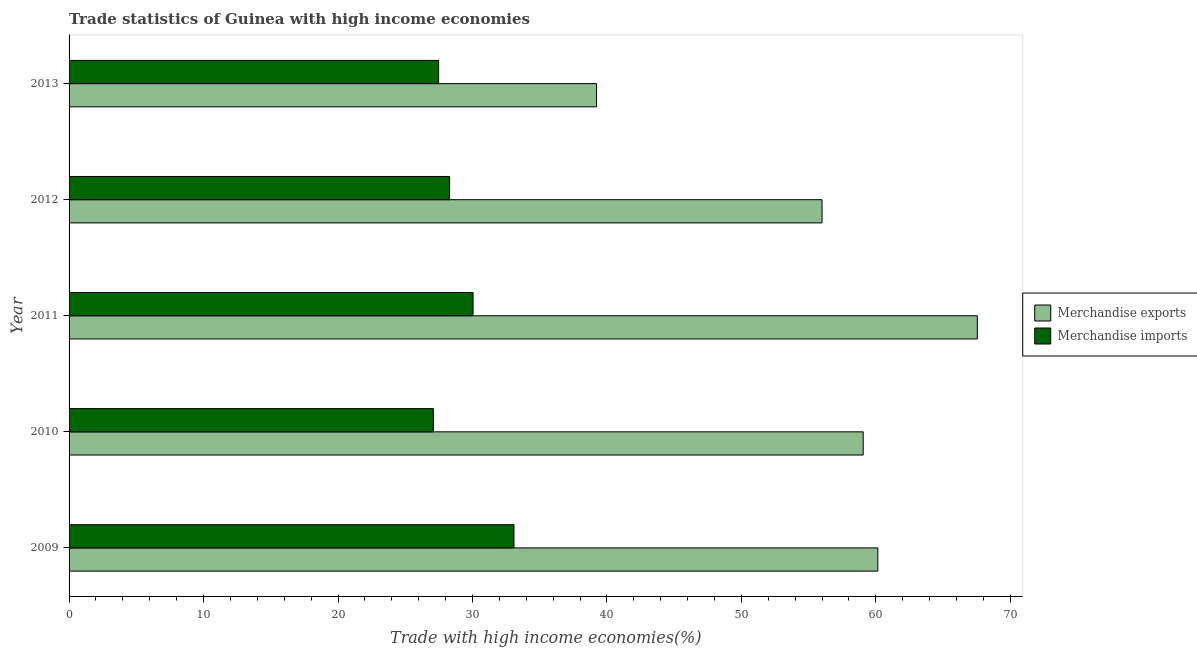Are the number of bars per tick equal to the number of legend labels?
Provide a short and direct response. Yes. Are the number of bars on each tick of the Y-axis equal?
Your response must be concise. Yes. In how many cases, is the number of bars for a given year not equal to the number of legend labels?
Offer a very short reply. 0. What is the merchandise exports in 2013?
Provide a short and direct response. 39.23. Across all years, what is the maximum merchandise imports?
Your response must be concise. 33.09. Across all years, what is the minimum merchandise imports?
Keep it short and to the point. 27.09. In which year was the merchandise exports minimum?
Your response must be concise. 2013. What is the total merchandise imports in the graph?
Make the answer very short. 146.01. What is the difference between the merchandise exports in 2009 and that in 2011?
Keep it short and to the point. -7.4. What is the difference between the merchandise imports in 2009 and the merchandise exports in 2013?
Keep it short and to the point. -6.14. What is the average merchandise imports per year?
Give a very brief answer. 29.2. In the year 2010, what is the difference between the merchandise imports and merchandise exports?
Your answer should be compact. -31.96. What is the ratio of the merchandise exports in 2009 to that in 2013?
Keep it short and to the point. 1.53. Is the merchandise exports in 2009 less than that in 2012?
Ensure brevity in your answer.  No. Is the difference between the merchandise imports in 2010 and 2011 greater than the difference between the merchandise exports in 2010 and 2011?
Ensure brevity in your answer.  Yes. What is the difference between the highest and the second highest merchandise imports?
Offer a very short reply. 3.04. What is the difference between the highest and the lowest merchandise exports?
Offer a terse response. 28.32. Is the sum of the merchandise imports in 2012 and 2013 greater than the maximum merchandise exports across all years?
Make the answer very short. No. What does the 2nd bar from the top in 2013 represents?
Make the answer very short. Merchandise exports. How many bars are there?
Provide a short and direct response. 10. What is the difference between two consecutive major ticks on the X-axis?
Provide a short and direct response. 10. Are the values on the major ticks of X-axis written in scientific E-notation?
Your answer should be compact. No. Does the graph contain any zero values?
Give a very brief answer. No. Does the graph contain grids?
Provide a short and direct response. No. What is the title of the graph?
Your answer should be compact. Trade statistics of Guinea with high income economies. Does "Register a business" appear as one of the legend labels in the graph?
Provide a short and direct response. No. What is the label or title of the X-axis?
Your answer should be very brief. Trade with high income economies(%). What is the Trade with high income economies(%) in Merchandise exports in 2009?
Provide a short and direct response. 60.15. What is the Trade with high income economies(%) in Merchandise imports in 2009?
Offer a very short reply. 33.09. What is the Trade with high income economies(%) in Merchandise exports in 2010?
Your answer should be compact. 59.06. What is the Trade with high income economies(%) of Merchandise imports in 2010?
Your answer should be very brief. 27.09. What is the Trade with high income economies(%) in Merchandise exports in 2011?
Ensure brevity in your answer.  67.55. What is the Trade with high income economies(%) of Merchandise imports in 2011?
Give a very brief answer. 30.05. What is the Trade with high income economies(%) in Merchandise exports in 2012?
Keep it short and to the point. 56. What is the Trade with high income economies(%) in Merchandise imports in 2012?
Your answer should be very brief. 28.3. What is the Trade with high income economies(%) in Merchandise exports in 2013?
Offer a terse response. 39.23. What is the Trade with high income economies(%) of Merchandise imports in 2013?
Ensure brevity in your answer.  27.48. Across all years, what is the maximum Trade with high income economies(%) of Merchandise exports?
Provide a succinct answer. 67.55. Across all years, what is the maximum Trade with high income economies(%) of Merchandise imports?
Offer a very short reply. 33.09. Across all years, what is the minimum Trade with high income economies(%) in Merchandise exports?
Your answer should be very brief. 39.23. Across all years, what is the minimum Trade with high income economies(%) in Merchandise imports?
Offer a terse response. 27.09. What is the total Trade with high income economies(%) in Merchandise exports in the graph?
Ensure brevity in your answer.  281.98. What is the total Trade with high income economies(%) in Merchandise imports in the graph?
Give a very brief answer. 146.01. What is the difference between the Trade with high income economies(%) of Merchandise exports in 2009 and that in 2010?
Keep it short and to the point. 1.09. What is the difference between the Trade with high income economies(%) of Merchandise imports in 2009 and that in 2010?
Make the answer very short. 5.99. What is the difference between the Trade with high income economies(%) in Merchandise exports in 2009 and that in 2011?
Give a very brief answer. -7.4. What is the difference between the Trade with high income economies(%) in Merchandise imports in 2009 and that in 2011?
Ensure brevity in your answer.  3.04. What is the difference between the Trade with high income economies(%) in Merchandise exports in 2009 and that in 2012?
Offer a terse response. 4.15. What is the difference between the Trade with high income economies(%) of Merchandise imports in 2009 and that in 2012?
Your answer should be very brief. 4.79. What is the difference between the Trade with high income economies(%) in Merchandise exports in 2009 and that in 2013?
Ensure brevity in your answer.  20.92. What is the difference between the Trade with high income economies(%) in Merchandise imports in 2009 and that in 2013?
Provide a short and direct response. 5.6. What is the difference between the Trade with high income economies(%) of Merchandise exports in 2010 and that in 2011?
Make the answer very short. -8.49. What is the difference between the Trade with high income economies(%) of Merchandise imports in 2010 and that in 2011?
Offer a terse response. -2.95. What is the difference between the Trade with high income economies(%) in Merchandise exports in 2010 and that in 2012?
Ensure brevity in your answer.  3.06. What is the difference between the Trade with high income economies(%) in Merchandise imports in 2010 and that in 2012?
Your response must be concise. -1.2. What is the difference between the Trade with high income economies(%) in Merchandise exports in 2010 and that in 2013?
Give a very brief answer. 19.83. What is the difference between the Trade with high income economies(%) of Merchandise imports in 2010 and that in 2013?
Your answer should be very brief. -0.39. What is the difference between the Trade with high income economies(%) of Merchandise exports in 2011 and that in 2012?
Your answer should be compact. 11.55. What is the difference between the Trade with high income economies(%) in Merchandise imports in 2011 and that in 2012?
Provide a short and direct response. 1.75. What is the difference between the Trade with high income economies(%) in Merchandise exports in 2011 and that in 2013?
Provide a succinct answer. 28.32. What is the difference between the Trade with high income economies(%) in Merchandise imports in 2011 and that in 2013?
Ensure brevity in your answer.  2.56. What is the difference between the Trade with high income economies(%) in Merchandise exports in 2012 and that in 2013?
Offer a terse response. 16.77. What is the difference between the Trade with high income economies(%) of Merchandise imports in 2012 and that in 2013?
Keep it short and to the point. 0.81. What is the difference between the Trade with high income economies(%) in Merchandise exports in 2009 and the Trade with high income economies(%) in Merchandise imports in 2010?
Make the answer very short. 33.05. What is the difference between the Trade with high income economies(%) of Merchandise exports in 2009 and the Trade with high income economies(%) of Merchandise imports in 2011?
Your answer should be very brief. 30.1. What is the difference between the Trade with high income economies(%) of Merchandise exports in 2009 and the Trade with high income economies(%) of Merchandise imports in 2012?
Keep it short and to the point. 31.85. What is the difference between the Trade with high income economies(%) in Merchandise exports in 2009 and the Trade with high income economies(%) in Merchandise imports in 2013?
Ensure brevity in your answer.  32.66. What is the difference between the Trade with high income economies(%) of Merchandise exports in 2010 and the Trade with high income economies(%) of Merchandise imports in 2011?
Offer a very short reply. 29.01. What is the difference between the Trade with high income economies(%) of Merchandise exports in 2010 and the Trade with high income economies(%) of Merchandise imports in 2012?
Your answer should be compact. 30.76. What is the difference between the Trade with high income economies(%) in Merchandise exports in 2010 and the Trade with high income economies(%) in Merchandise imports in 2013?
Make the answer very short. 31.57. What is the difference between the Trade with high income economies(%) in Merchandise exports in 2011 and the Trade with high income economies(%) in Merchandise imports in 2012?
Provide a short and direct response. 39.25. What is the difference between the Trade with high income economies(%) of Merchandise exports in 2011 and the Trade with high income economies(%) of Merchandise imports in 2013?
Your answer should be compact. 40.06. What is the difference between the Trade with high income economies(%) in Merchandise exports in 2012 and the Trade with high income economies(%) in Merchandise imports in 2013?
Ensure brevity in your answer.  28.51. What is the average Trade with high income economies(%) of Merchandise exports per year?
Your answer should be very brief. 56.4. What is the average Trade with high income economies(%) in Merchandise imports per year?
Your answer should be compact. 29.2. In the year 2009, what is the difference between the Trade with high income economies(%) in Merchandise exports and Trade with high income economies(%) in Merchandise imports?
Make the answer very short. 27.06. In the year 2010, what is the difference between the Trade with high income economies(%) in Merchandise exports and Trade with high income economies(%) in Merchandise imports?
Offer a very short reply. 31.96. In the year 2011, what is the difference between the Trade with high income economies(%) of Merchandise exports and Trade with high income economies(%) of Merchandise imports?
Your response must be concise. 37.5. In the year 2012, what is the difference between the Trade with high income economies(%) in Merchandise exports and Trade with high income economies(%) in Merchandise imports?
Your answer should be compact. 27.7. In the year 2013, what is the difference between the Trade with high income economies(%) in Merchandise exports and Trade with high income economies(%) in Merchandise imports?
Your response must be concise. 11.74. What is the ratio of the Trade with high income economies(%) in Merchandise exports in 2009 to that in 2010?
Keep it short and to the point. 1.02. What is the ratio of the Trade with high income economies(%) of Merchandise imports in 2009 to that in 2010?
Your answer should be very brief. 1.22. What is the ratio of the Trade with high income economies(%) of Merchandise exports in 2009 to that in 2011?
Provide a short and direct response. 0.89. What is the ratio of the Trade with high income economies(%) of Merchandise imports in 2009 to that in 2011?
Provide a succinct answer. 1.1. What is the ratio of the Trade with high income economies(%) of Merchandise exports in 2009 to that in 2012?
Ensure brevity in your answer.  1.07. What is the ratio of the Trade with high income economies(%) in Merchandise imports in 2009 to that in 2012?
Offer a very short reply. 1.17. What is the ratio of the Trade with high income economies(%) in Merchandise exports in 2009 to that in 2013?
Your answer should be compact. 1.53. What is the ratio of the Trade with high income economies(%) in Merchandise imports in 2009 to that in 2013?
Your answer should be very brief. 1.2. What is the ratio of the Trade with high income economies(%) of Merchandise exports in 2010 to that in 2011?
Provide a short and direct response. 0.87. What is the ratio of the Trade with high income economies(%) of Merchandise imports in 2010 to that in 2011?
Ensure brevity in your answer.  0.9. What is the ratio of the Trade with high income economies(%) in Merchandise exports in 2010 to that in 2012?
Provide a succinct answer. 1.05. What is the ratio of the Trade with high income economies(%) of Merchandise imports in 2010 to that in 2012?
Ensure brevity in your answer.  0.96. What is the ratio of the Trade with high income economies(%) in Merchandise exports in 2010 to that in 2013?
Offer a terse response. 1.51. What is the ratio of the Trade with high income economies(%) in Merchandise imports in 2010 to that in 2013?
Offer a terse response. 0.99. What is the ratio of the Trade with high income economies(%) of Merchandise exports in 2011 to that in 2012?
Your answer should be compact. 1.21. What is the ratio of the Trade with high income economies(%) of Merchandise imports in 2011 to that in 2012?
Your answer should be very brief. 1.06. What is the ratio of the Trade with high income economies(%) in Merchandise exports in 2011 to that in 2013?
Offer a very short reply. 1.72. What is the ratio of the Trade with high income economies(%) of Merchandise imports in 2011 to that in 2013?
Provide a short and direct response. 1.09. What is the ratio of the Trade with high income economies(%) of Merchandise exports in 2012 to that in 2013?
Provide a short and direct response. 1.43. What is the ratio of the Trade with high income economies(%) in Merchandise imports in 2012 to that in 2013?
Your response must be concise. 1.03. What is the difference between the highest and the second highest Trade with high income economies(%) in Merchandise exports?
Offer a terse response. 7.4. What is the difference between the highest and the second highest Trade with high income economies(%) of Merchandise imports?
Your answer should be very brief. 3.04. What is the difference between the highest and the lowest Trade with high income economies(%) of Merchandise exports?
Provide a short and direct response. 28.32. What is the difference between the highest and the lowest Trade with high income economies(%) in Merchandise imports?
Your answer should be compact. 5.99. 